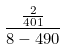Convert formula to latex. <formula><loc_0><loc_0><loc_500><loc_500>\frac { \frac { 2 } { 4 0 1 } } { 8 - 4 9 0 }</formula> 